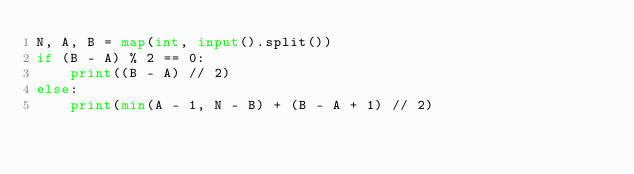<code> <loc_0><loc_0><loc_500><loc_500><_Python_>N, A, B = map(int, input().split())
if (B - A) % 2 == 0:
    print((B - A) // 2)
else:
    print(min(A - 1, N - B) + (B - A + 1) // 2)
</code> 